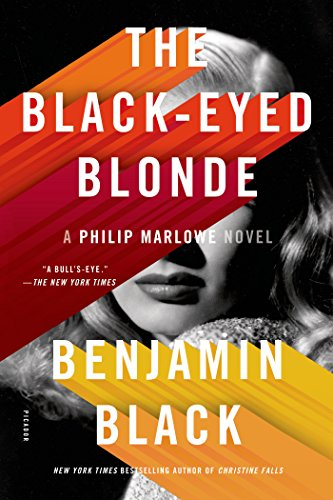Can you describe the character of Philip Marlowe in this novel? Philip Marlowe, the central character in this novel, is depicted as a shrewd and morally upright private detective, known for his wit, tough exterior, and deep sense of justice. He navigates the murky waters of crime and corruption in Los Angeles, frequently becoming a champion for the oppressed. 